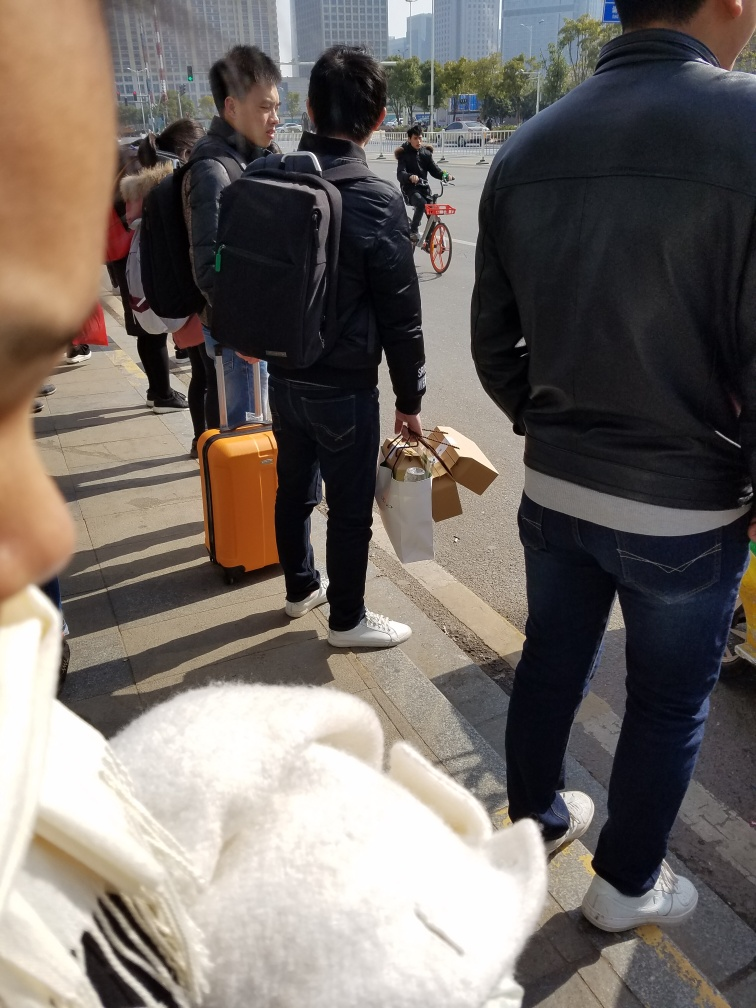Can you describe the attire of the people in the image? The people are dressed in casual to smart casual attire. Coats, backpacks, and jeans are visible, suggesting a casual or travel-related setting. The attire is in line with the cooler temperate weather suggested by the presence of outerwear. 